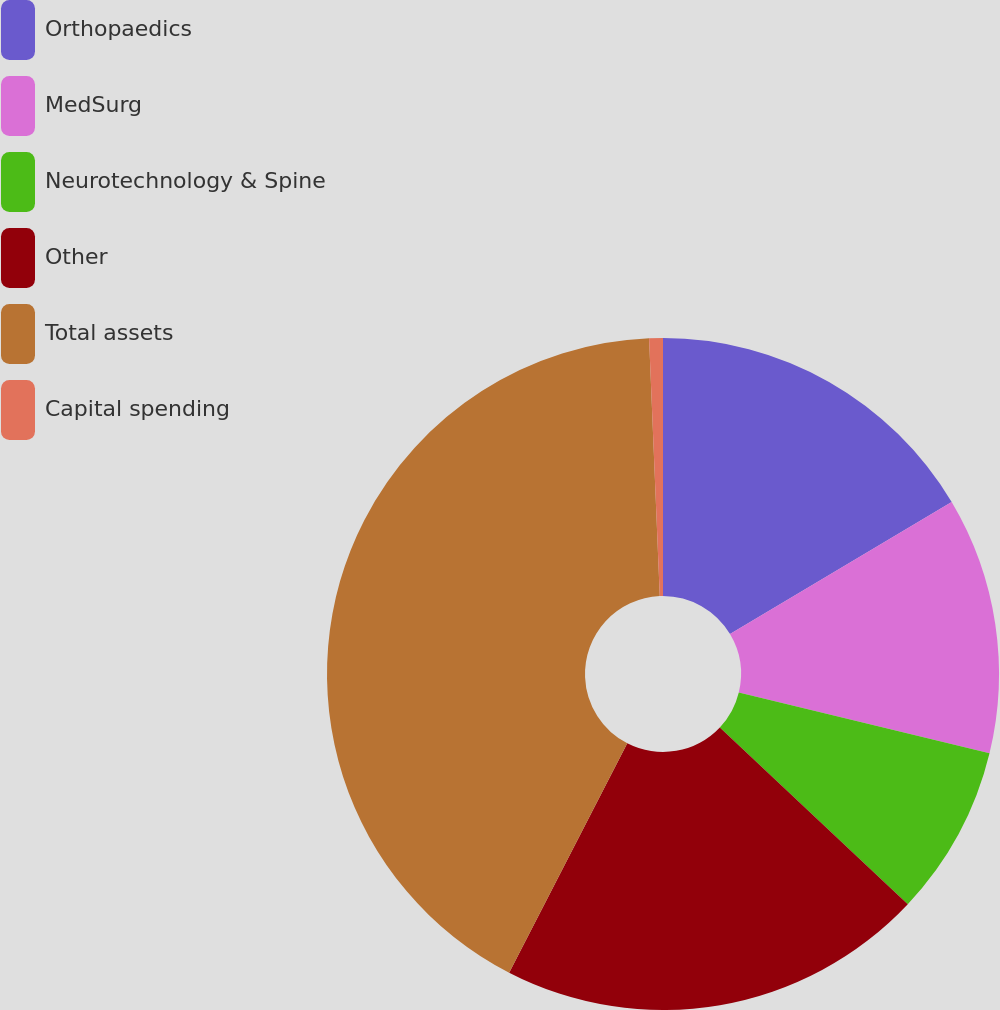<chart> <loc_0><loc_0><loc_500><loc_500><pie_chart><fcel>Orthopaedics<fcel>MedSurg<fcel>Neurotechnology & Spine<fcel>Other<fcel>Total assets<fcel>Capital spending<nl><fcel>16.45%<fcel>12.34%<fcel>8.22%<fcel>20.56%<fcel>41.77%<fcel>0.66%<nl></chart> 